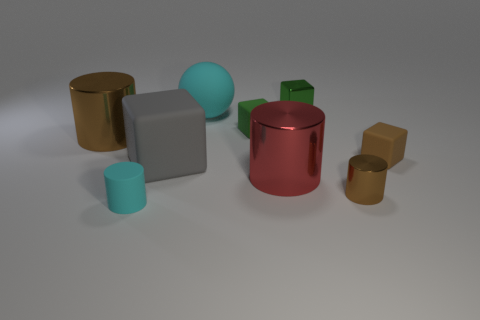Are there any other things that have the same material as the gray object?
Make the answer very short. Yes. What material is the green block that is in front of the tiny metal object that is behind the metal cylinder behind the big gray cube?
Keep it short and to the point. Rubber. There is a small object that is the same color as the metal block; what is it made of?
Offer a very short reply. Rubber. How many big red cylinders are the same material as the brown cube?
Ensure brevity in your answer.  0. Is the size of the shiny cylinder on the left side of the red thing the same as the big cyan rubber object?
Offer a very short reply. Yes. What color is the block that is made of the same material as the red cylinder?
Your response must be concise. Green. There is a gray block; what number of tiny brown objects are in front of it?
Give a very brief answer. 1. Do the tiny cylinder that is right of the small rubber cylinder and the large shiny thing right of the ball have the same color?
Provide a succinct answer. No. What is the color of the other large shiny thing that is the same shape as the red object?
Offer a terse response. Brown. Are there any other things that have the same shape as the small green metallic object?
Offer a very short reply. Yes. 